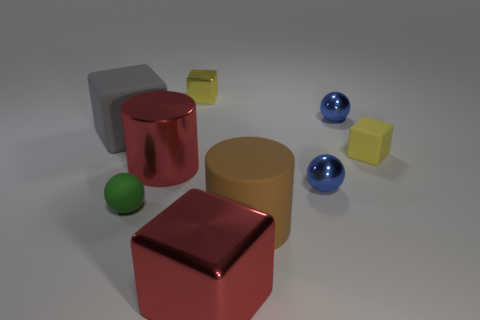Subtract all cylinders. How many objects are left? 7 Add 1 tiny yellow metallic things. How many objects exist? 10 Subtract all red metallic cubes. Subtract all big brown objects. How many objects are left? 7 Add 2 big brown matte objects. How many big brown matte objects are left? 3 Add 4 tiny spheres. How many tiny spheres exist? 7 Subtract 1 red cylinders. How many objects are left? 8 